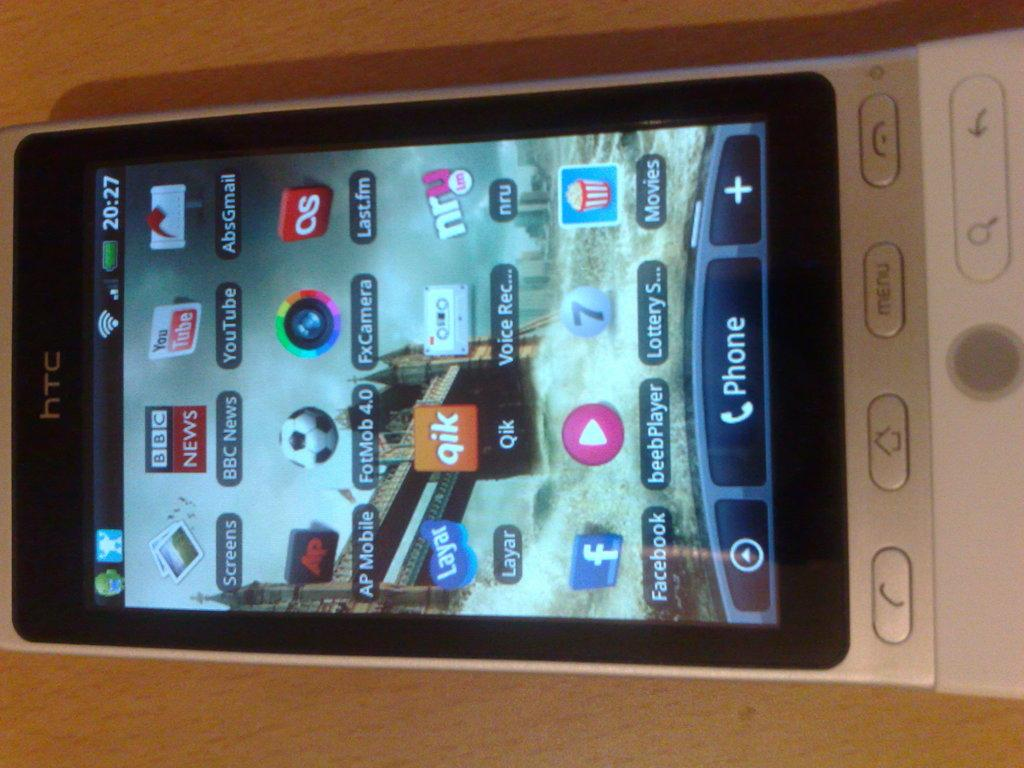<image>
Summarize the visual content of the image. Phone screen with the Facebook app on the lower left. 